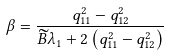Convert formula to latex. <formula><loc_0><loc_0><loc_500><loc_500>\beta = \frac { q _ { 1 1 } ^ { 2 } - q _ { 1 2 } ^ { 2 } } { \widetilde { B } \lambda _ { 1 } + 2 \left ( q _ { 1 1 } ^ { 2 } - q _ { 1 2 } ^ { 2 } \right ) }</formula> 